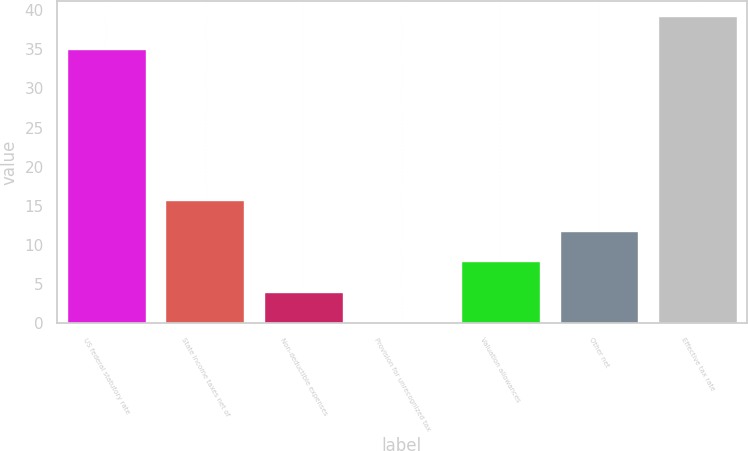<chart> <loc_0><loc_0><loc_500><loc_500><bar_chart><fcel>US federal statutory rate<fcel>State income taxes net of<fcel>Non-deductible expenses<fcel>Provision for unrecognized tax<fcel>Valuation allowances<fcel>Other net<fcel>Effective tax rate<nl><fcel>35<fcel>15.74<fcel>4.01<fcel>0.1<fcel>7.92<fcel>11.83<fcel>39.2<nl></chart> 